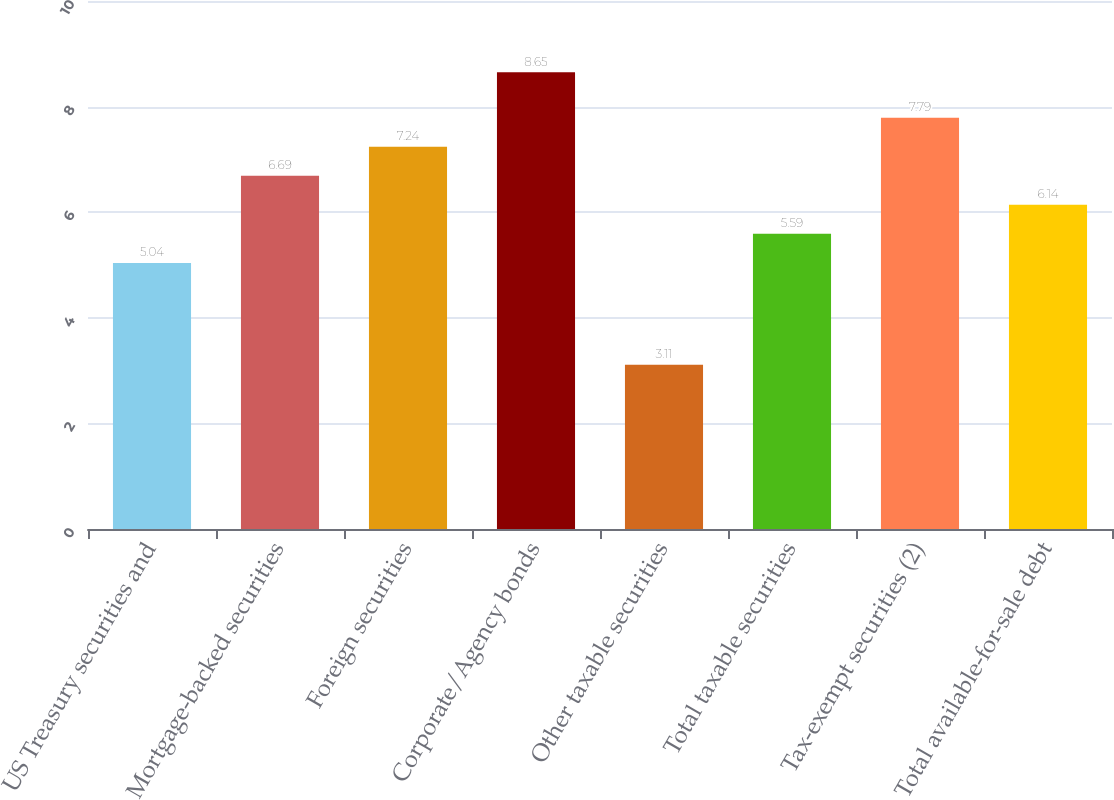Convert chart to OTSL. <chart><loc_0><loc_0><loc_500><loc_500><bar_chart><fcel>US Treasury securities and<fcel>Mortgage-backed securities<fcel>Foreign securities<fcel>Corporate/Agency bonds<fcel>Other taxable securities<fcel>Total taxable securities<fcel>Tax-exempt securities (2)<fcel>Total available-for-sale debt<nl><fcel>5.04<fcel>6.69<fcel>7.24<fcel>8.65<fcel>3.11<fcel>5.59<fcel>7.79<fcel>6.14<nl></chart> 